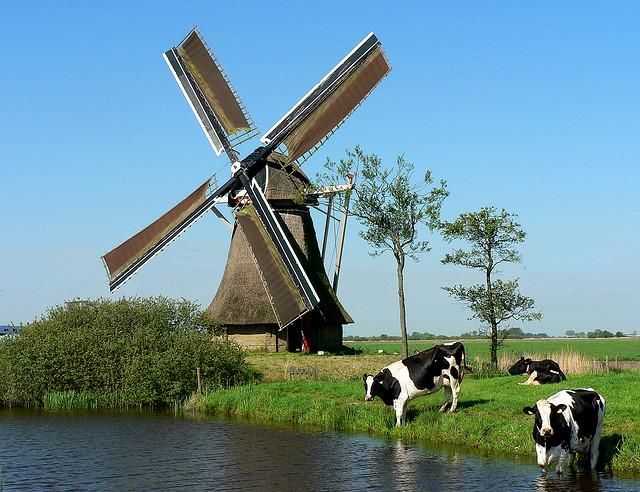What does the building do? spin 